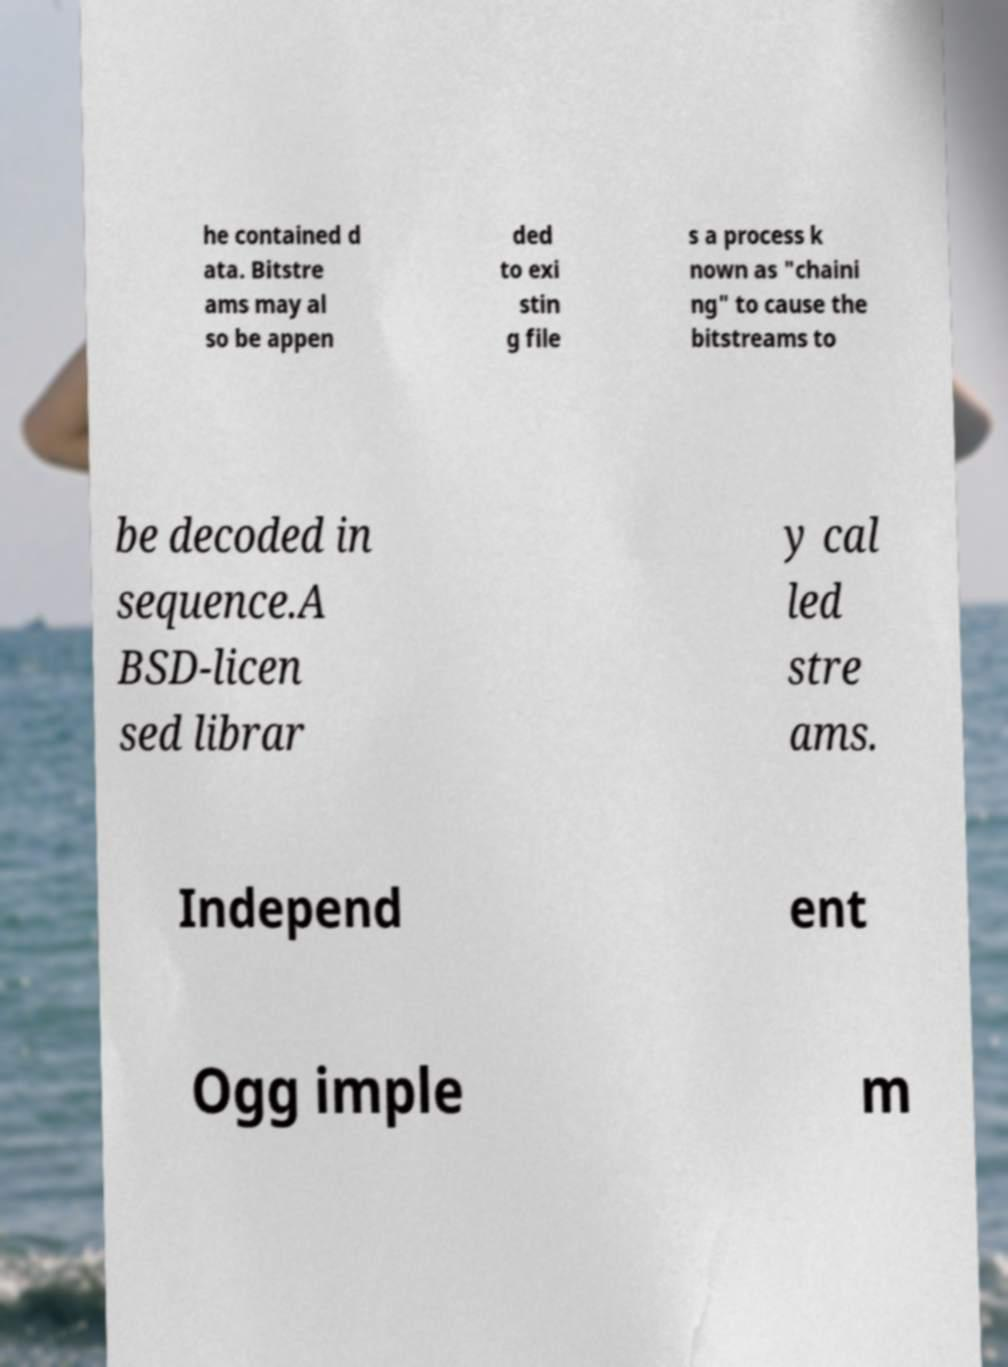There's text embedded in this image that I need extracted. Can you transcribe it verbatim? he contained d ata. Bitstre ams may al so be appen ded to exi stin g file s a process k nown as "chaini ng" to cause the bitstreams to be decoded in sequence.A BSD-licen sed librar y cal led stre ams. Independ ent Ogg imple m 